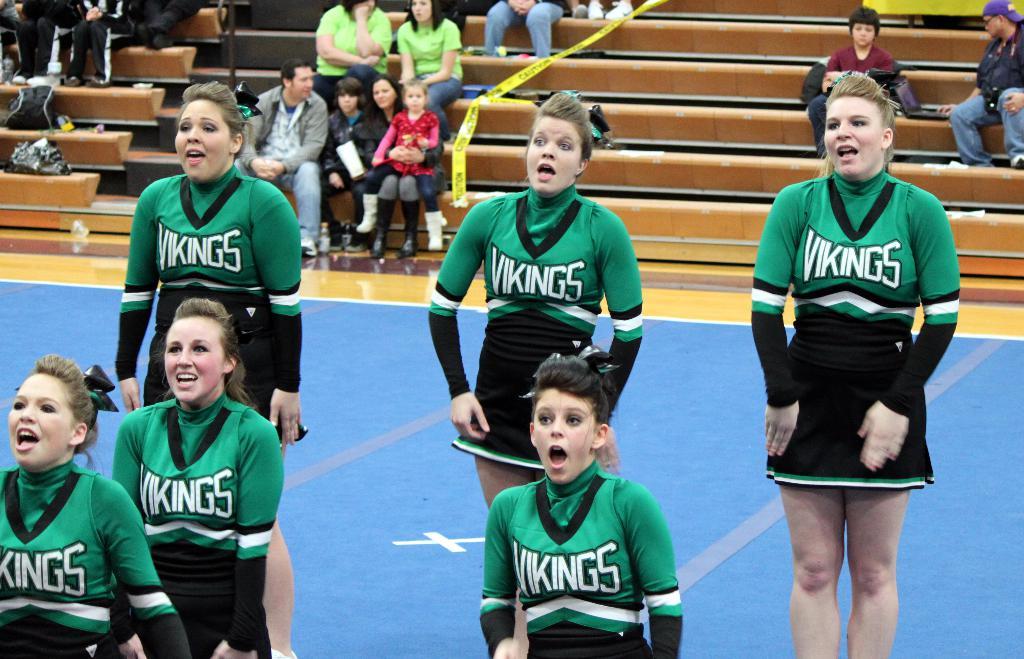What team do the cheerleaders support?
Give a very brief answer. Vikings. What color is the word "vikings" on their jersey?
Keep it short and to the point. White. 